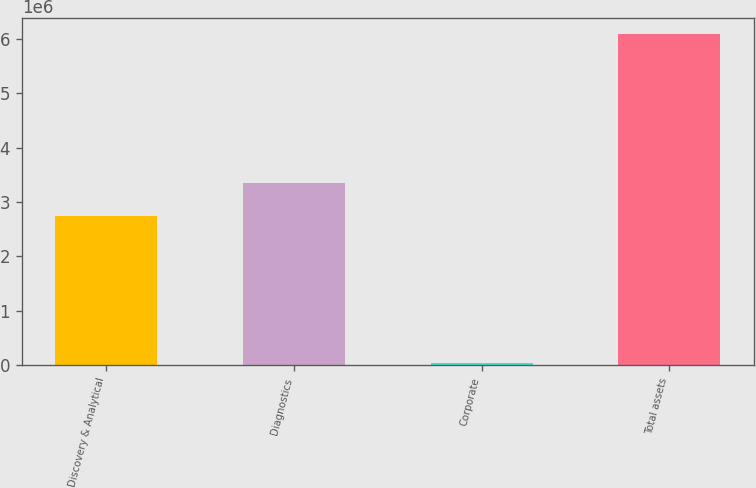Convert chart. <chart><loc_0><loc_0><loc_500><loc_500><bar_chart><fcel>Discovery & Analytical<fcel>Diagnostics<fcel>Corporate<fcel>Total assets<nl><fcel>2.74437e+06<fcel>3.35029e+06<fcel>32289<fcel>6.09146e+06<nl></chart> 